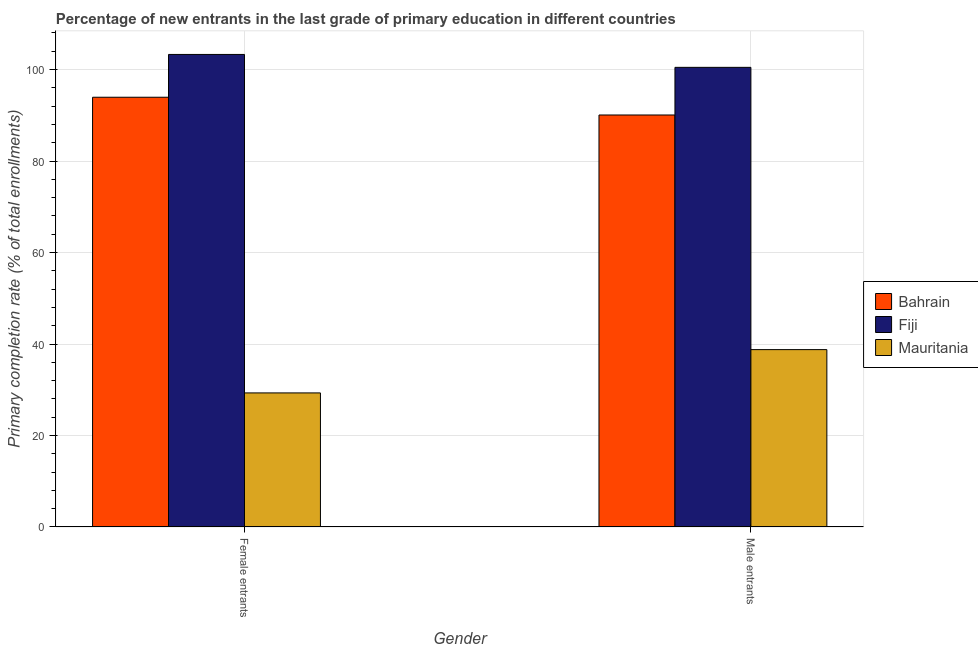How many groups of bars are there?
Offer a terse response. 2. Are the number of bars per tick equal to the number of legend labels?
Your answer should be very brief. Yes. Are the number of bars on each tick of the X-axis equal?
Keep it short and to the point. Yes. How many bars are there on the 2nd tick from the right?
Offer a terse response. 3. What is the label of the 2nd group of bars from the left?
Provide a short and direct response. Male entrants. What is the primary completion rate of female entrants in Mauritania?
Your response must be concise. 29.31. Across all countries, what is the maximum primary completion rate of male entrants?
Offer a very short reply. 100.48. Across all countries, what is the minimum primary completion rate of female entrants?
Make the answer very short. 29.31. In which country was the primary completion rate of male entrants maximum?
Your response must be concise. Fiji. In which country was the primary completion rate of male entrants minimum?
Offer a very short reply. Mauritania. What is the total primary completion rate of female entrants in the graph?
Ensure brevity in your answer.  226.55. What is the difference between the primary completion rate of female entrants in Fiji and that in Mauritania?
Offer a very short reply. 73.99. What is the difference between the primary completion rate of female entrants in Fiji and the primary completion rate of male entrants in Bahrain?
Provide a short and direct response. 13.23. What is the average primary completion rate of female entrants per country?
Give a very brief answer. 75.52. What is the difference between the primary completion rate of female entrants and primary completion rate of male entrants in Mauritania?
Keep it short and to the point. -9.46. What is the ratio of the primary completion rate of male entrants in Mauritania to that in Bahrain?
Keep it short and to the point. 0.43. In how many countries, is the primary completion rate of male entrants greater than the average primary completion rate of male entrants taken over all countries?
Give a very brief answer. 2. What does the 1st bar from the left in Female entrants represents?
Provide a succinct answer. Bahrain. What does the 3rd bar from the right in Male entrants represents?
Your answer should be very brief. Bahrain. How many bars are there?
Your response must be concise. 6. Are all the bars in the graph horizontal?
Your answer should be compact. No. Are the values on the major ticks of Y-axis written in scientific E-notation?
Provide a short and direct response. No. Where does the legend appear in the graph?
Provide a succinct answer. Center right. What is the title of the graph?
Your answer should be compact. Percentage of new entrants in the last grade of primary education in different countries. Does "Turkey" appear as one of the legend labels in the graph?
Your response must be concise. No. What is the label or title of the X-axis?
Ensure brevity in your answer.  Gender. What is the label or title of the Y-axis?
Offer a very short reply. Primary completion rate (% of total enrollments). What is the Primary completion rate (% of total enrollments) in Bahrain in Female entrants?
Offer a very short reply. 93.94. What is the Primary completion rate (% of total enrollments) in Fiji in Female entrants?
Ensure brevity in your answer.  103.3. What is the Primary completion rate (% of total enrollments) of Mauritania in Female entrants?
Provide a succinct answer. 29.31. What is the Primary completion rate (% of total enrollments) of Bahrain in Male entrants?
Make the answer very short. 90.06. What is the Primary completion rate (% of total enrollments) of Fiji in Male entrants?
Your answer should be compact. 100.48. What is the Primary completion rate (% of total enrollments) of Mauritania in Male entrants?
Offer a terse response. 38.77. Across all Gender, what is the maximum Primary completion rate (% of total enrollments) in Bahrain?
Offer a very short reply. 93.94. Across all Gender, what is the maximum Primary completion rate (% of total enrollments) in Fiji?
Your response must be concise. 103.3. Across all Gender, what is the maximum Primary completion rate (% of total enrollments) in Mauritania?
Your answer should be compact. 38.77. Across all Gender, what is the minimum Primary completion rate (% of total enrollments) in Bahrain?
Your answer should be very brief. 90.06. Across all Gender, what is the minimum Primary completion rate (% of total enrollments) in Fiji?
Your answer should be very brief. 100.48. Across all Gender, what is the minimum Primary completion rate (% of total enrollments) in Mauritania?
Provide a succinct answer. 29.31. What is the total Primary completion rate (% of total enrollments) in Bahrain in the graph?
Provide a succinct answer. 184.01. What is the total Primary completion rate (% of total enrollments) of Fiji in the graph?
Make the answer very short. 203.77. What is the total Primary completion rate (% of total enrollments) in Mauritania in the graph?
Provide a short and direct response. 68.08. What is the difference between the Primary completion rate (% of total enrollments) in Bahrain in Female entrants and that in Male entrants?
Make the answer very short. 3.88. What is the difference between the Primary completion rate (% of total enrollments) of Fiji in Female entrants and that in Male entrants?
Ensure brevity in your answer.  2.82. What is the difference between the Primary completion rate (% of total enrollments) of Mauritania in Female entrants and that in Male entrants?
Your response must be concise. -9.46. What is the difference between the Primary completion rate (% of total enrollments) of Bahrain in Female entrants and the Primary completion rate (% of total enrollments) of Fiji in Male entrants?
Your answer should be compact. -6.53. What is the difference between the Primary completion rate (% of total enrollments) of Bahrain in Female entrants and the Primary completion rate (% of total enrollments) of Mauritania in Male entrants?
Your answer should be very brief. 55.17. What is the difference between the Primary completion rate (% of total enrollments) in Fiji in Female entrants and the Primary completion rate (% of total enrollments) in Mauritania in Male entrants?
Your response must be concise. 64.52. What is the average Primary completion rate (% of total enrollments) in Bahrain per Gender?
Give a very brief answer. 92. What is the average Primary completion rate (% of total enrollments) in Fiji per Gender?
Provide a succinct answer. 101.89. What is the average Primary completion rate (% of total enrollments) in Mauritania per Gender?
Make the answer very short. 34.04. What is the difference between the Primary completion rate (% of total enrollments) in Bahrain and Primary completion rate (% of total enrollments) in Fiji in Female entrants?
Offer a terse response. -9.35. What is the difference between the Primary completion rate (% of total enrollments) in Bahrain and Primary completion rate (% of total enrollments) in Mauritania in Female entrants?
Offer a terse response. 64.63. What is the difference between the Primary completion rate (% of total enrollments) of Fiji and Primary completion rate (% of total enrollments) of Mauritania in Female entrants?
Your answer should be compact. 73.99. What is the difference between the Primary completion rate (% of total enrollments) in Bahrain and Primary completion rate (% of total enrollments) in Fiji in Male entrants?
Ensure brevity in your answer.  -10.41. What is the difference between the Primary completion rate (% of total enrollments) in Bahrain and Primary completion rate (% of total enrollments) in Mauritania in Male entrants?
Provide a short and direct response. 51.29. What is the difference between the Primary completion rate (% of total enrollments) of Fiji and Primary completion rate (% of total enrollments) of Mauritania in Male entrants?
Make the answer very short. 61.7. What is the ratio of the Primary completion rate (% of total enrollments) in Bahrain in Female entrants to that in Male entrants?
Provide a succinct answer. 1.04. What is the ratio of the Primary completion rate (% of total enrollments) in Fiji in Female entrants to that in Male entrants?
Give a very brief answer. 1.03. What is the ratio of the Primary completion rate (% of total enrollments) of Mauritania in Female entrants to that in Male entrants?
Ensure brevity in your answer.  0.76. What is the difference between the highest and the second highest Primary completion rate (% of total enrollments) in Bahrain?
Ensure brevity in your answer.  3.88. What is the difference between the highest and the second highest Primary completion rate (% of total enrollments) in Fiji?
Your response must be concise. 2.82. What is the difference between the highest and the second highest Primary completion rate (% of total enrollments) of Mauritania?
Offer a terse response. 9.46. What is the difference between the highest and the lowest Primary completion rate (% of total enrollments) of Bahrain?
Your response must be concise. 3.88. What is the difference between the highest and the lowest Primary completion rate (% of total enrollments) of Fiji?
Provide a succinct answer. 2.82. What is the difference between the highest and the lowest Primary completion rate (% of total enrollments) of Mauritania?
Keep it short and to the point. 9.46. 